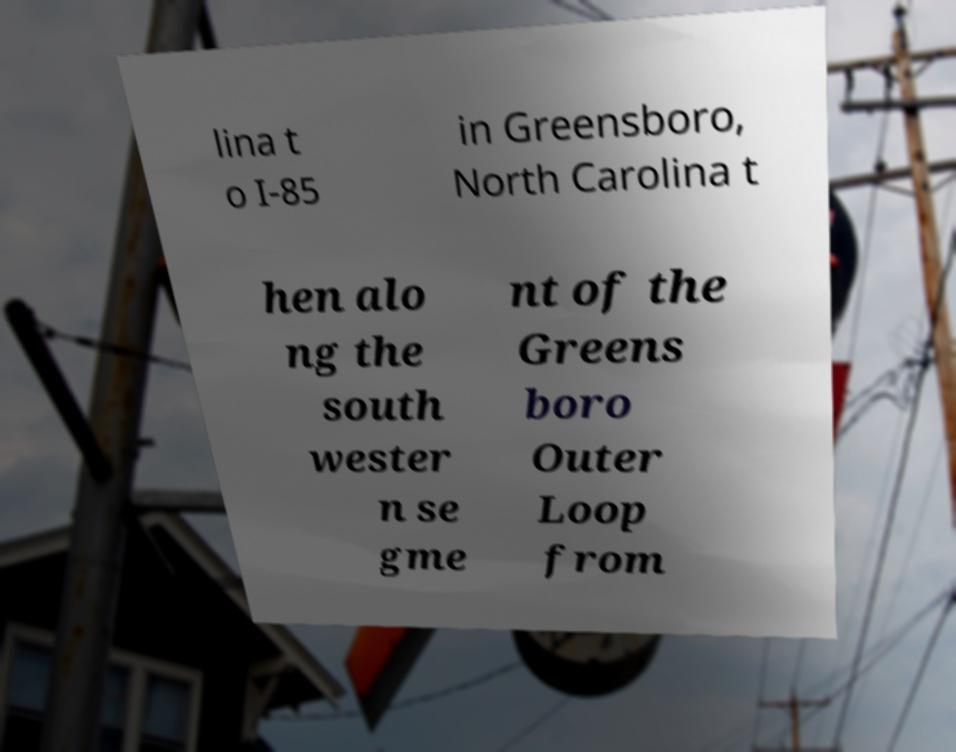Can you read and provide the text displayed in the image?This photo seems to have some interesting text. Can you extract and type it out for me? lina t o I-85 in Greensboro, North Carolina t hen alo ng the south wester n se gme nt of the Greens boro Outer Loop from 